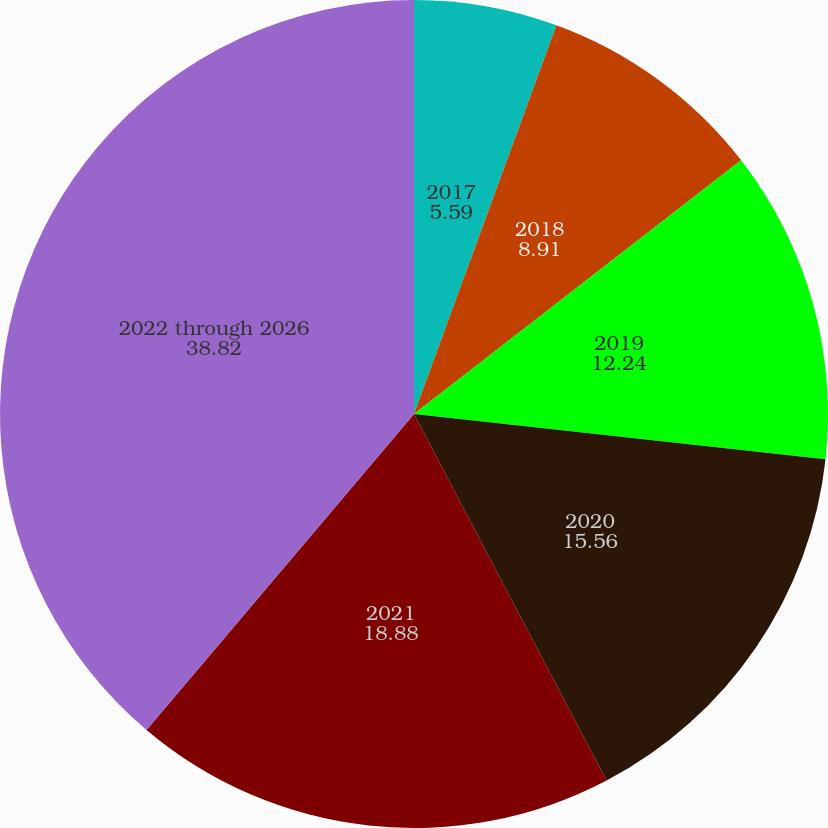Convert chart to OTSL. <chart><loc_0><loc_0><loc_500><loc_500><pie_chart><fcel>2017<fcel>2018<fcel>2019<fcel>2020<fcel>2021<fcel>2022 through 2026<nl><fcel>5.59%<fcel>8.91%<fcel>12.24%<fcel>15.56%<fcel>18.88%<fcel>38.82%<nl></chart> 